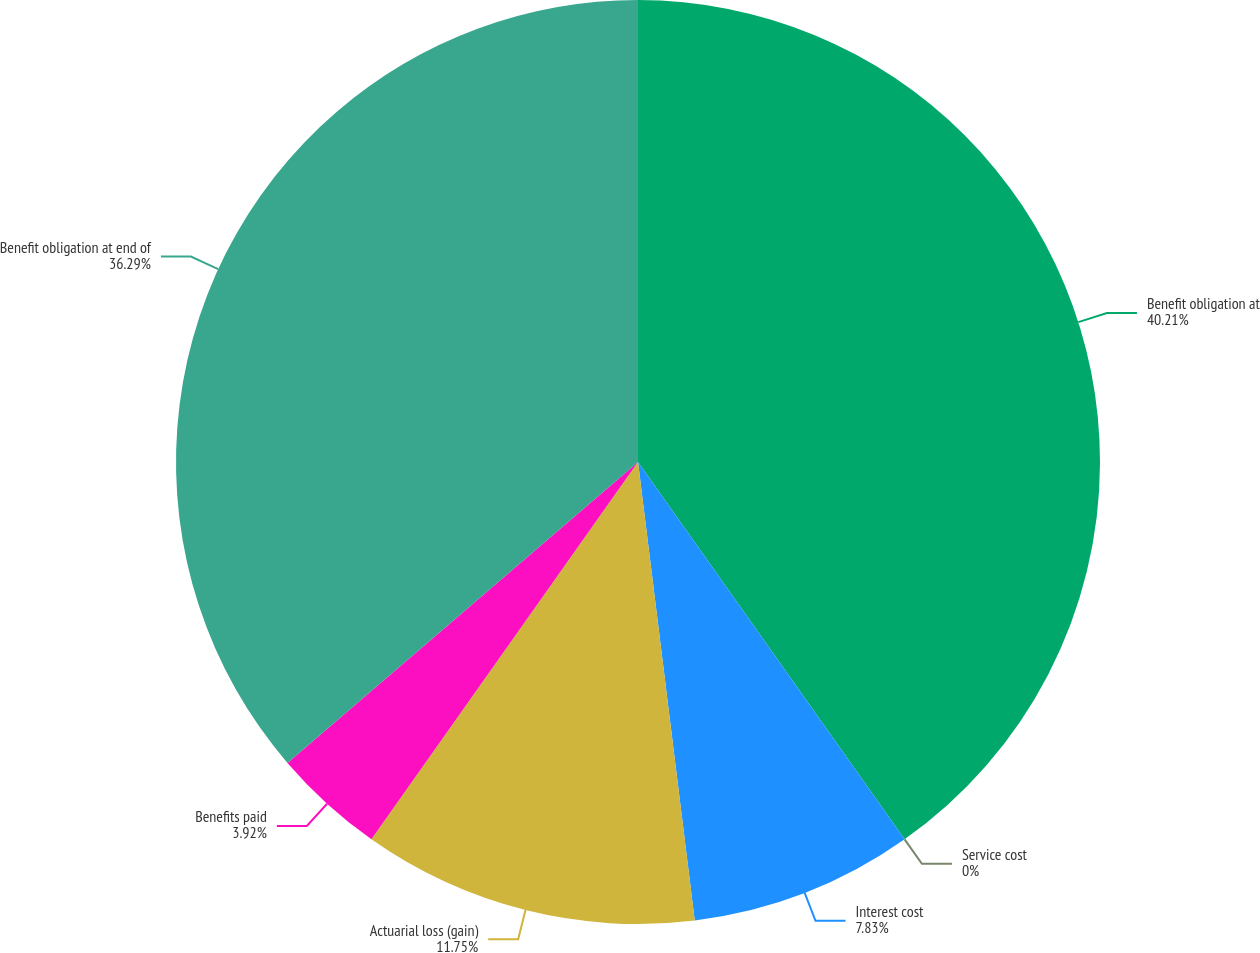Convert chart. <chart><loc_0><loc_0><loc_500><loc_500><pie_chart><fcel>Benefit obligation at<fcel>Service cost<fcel>Interest cost<fcel>Actuarial loss (gain)<fcel>Benefits paid<fcel>Benefit obligation at end of<nl><fcel>40.21%<fcel>0.0%<fcel>7.83%<fcel>11.75%<fcel>3.92%<fcel>36.29%<nl></chart> 